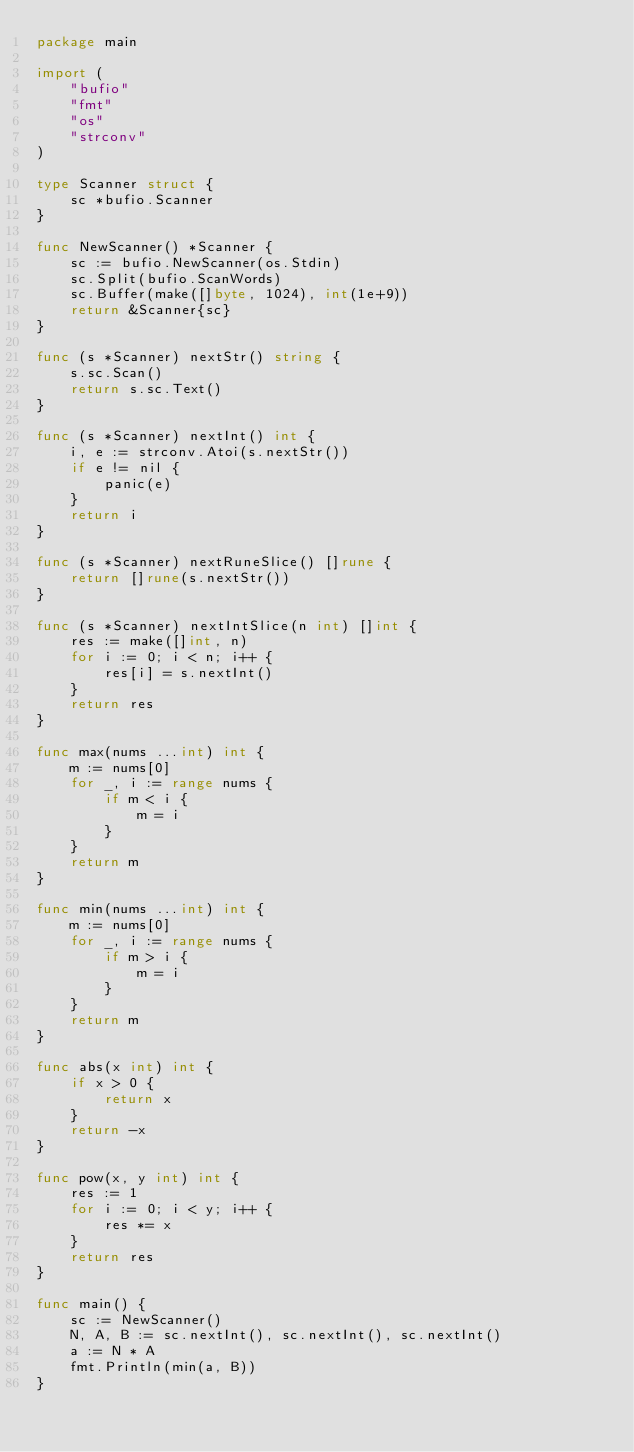<code> <loc_0><loc_0><loc_500><loc_500><_Go_>package main

import (
	"bufio"
	"fmt"
	"os"
	"strconv"
)

type Scanner struct {
	sc *bufio.Scanner
}

func NewScanner() *Scanner {
	sc := bufio.NewScanner(os.Stdin)
	sc.Split(bufio.ScanWords)
	sc.Buffer(make([]byte, 1024), int(1e+9))
	return &Scanner{sc}
}

func (s *Scanner) nextStr() string {
	s.sc.Scan()
	return s.sc.Text()
}

func (s *Scanner) nextInt() int {
	i, e := strconv.Atoi(s.nextStr())
	if e != nil {
		panic(e)
	}
	return i
}

func (s *Scanner) nextRuneSlice() []rune {
	return []rune(s.nextStr())
}

func (s *Scanner) nextIntSlice(n int) []int {
	res := make([]int, n)
	for i := 0; i < n; i++ {
		res[i] = s.nextInt()
	}
	return res
}

func max(nums ...int) int {
	m := nums[0]
	for _, i := range nums {
		if m < i {
			m = i
		}
	}
	return m
}

func min(nums ...int) int {
	m := nums[0]
	for _, i := range nums {
		if m > i {
			m = i
		}
	}
	return m
}

func abs(x int) int {
	if x > 0 {
		return x
	}
	return -x
}

func pow(x, y int) int {
	res := 1
	for i := 0; i < y; i++ {
		res *= x
	}
	return res
}

func main() {
	sc := NewScanner()
	N, A, B := sc.nextInt(), sc.nextInt(), sc.nextInt()
	a := N * A
	fmt.Println(min(a, B))
}
</code> 